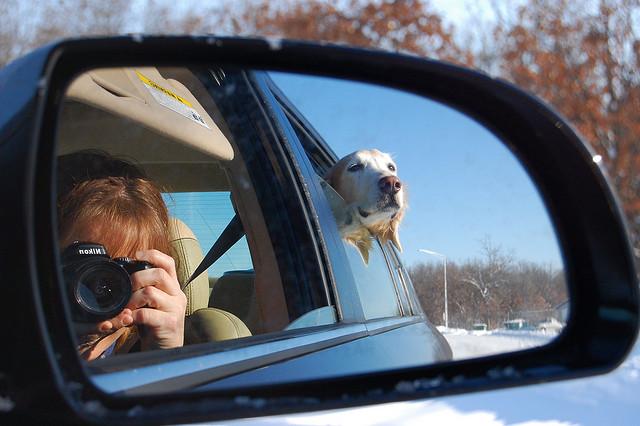Is it the dog or the dog's reflection?
Keep it brief. Reflection. Is this a vehicle?
Answer briefly. Yes. What is the woman doing?
Be succinct. Taking picture. 